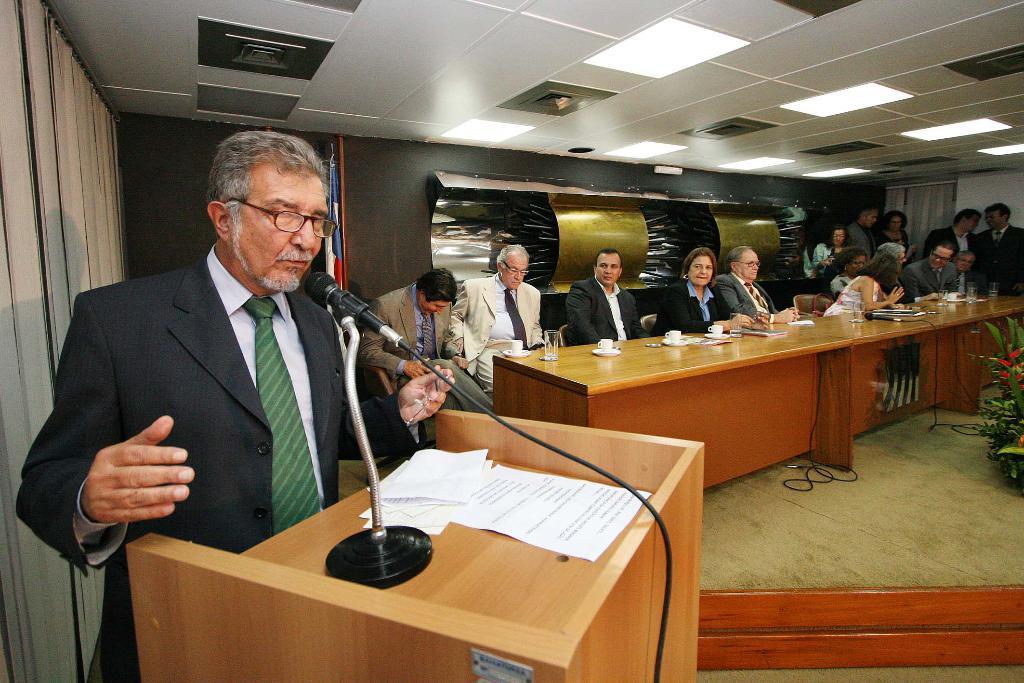Can you describe this image briefly? In this image I see a man who is standing in front of a podium and there are papers and mic on it. In the background I see few more people in which most of the them are sitting on chairs and rest of them are standing. I can also see a table in front of them on which there are cups, glasses and other things and I see a plant over here and lights on the ceiling. 